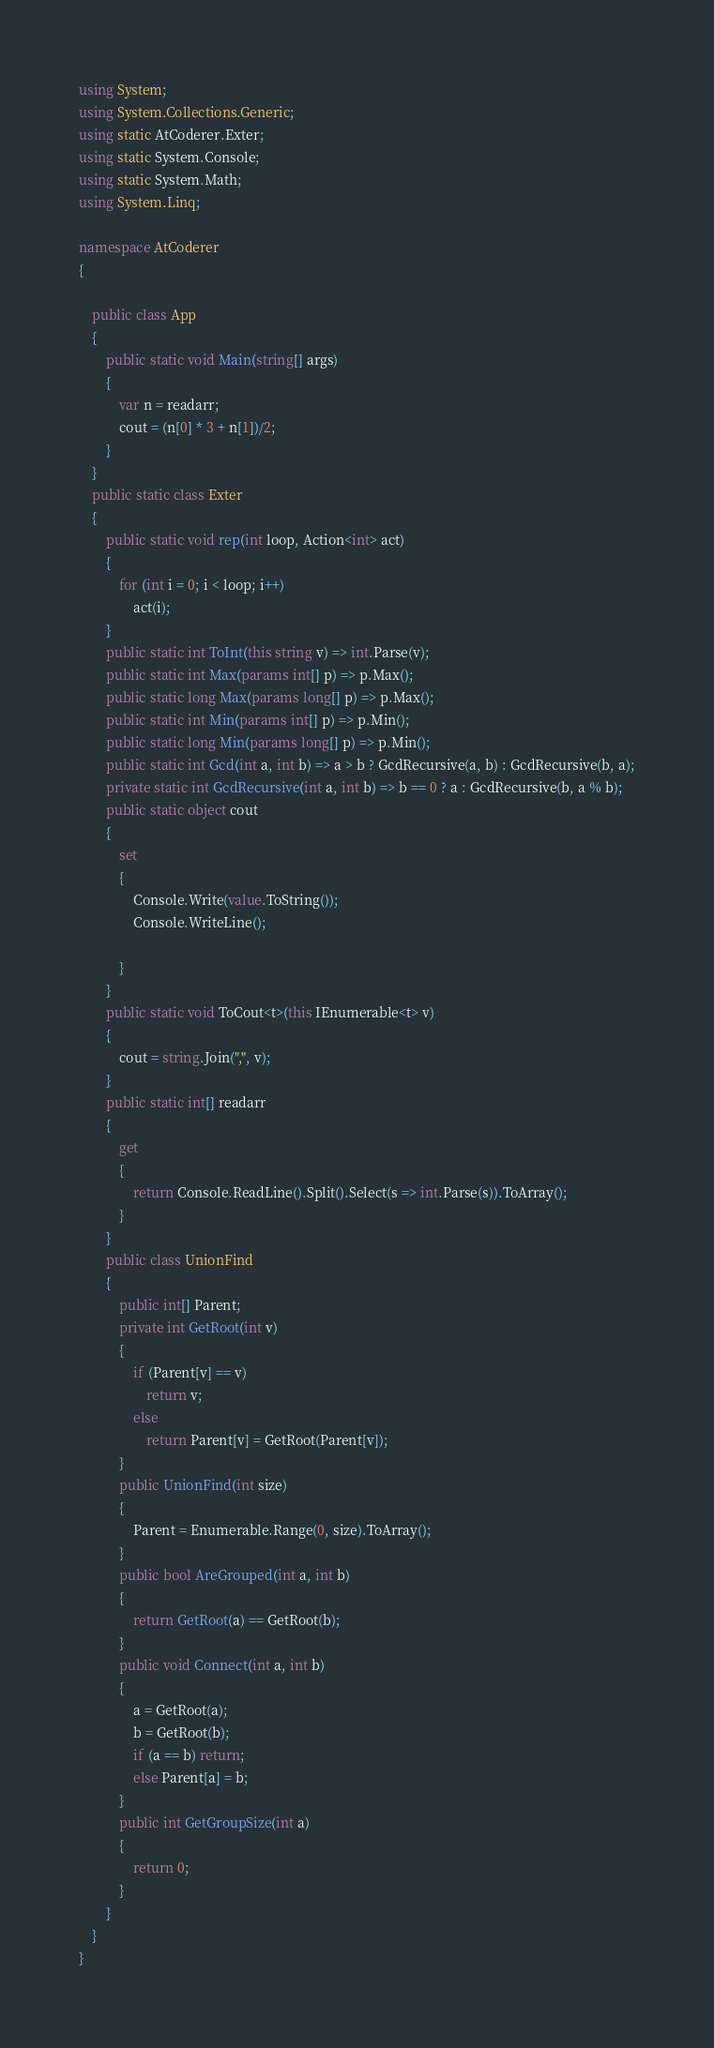<code> <loc_0><loc_0><loc_500><loc_500><_C#_>using System;
using System.Collections.Generic;
using static AtCoderer.Exter;
using static System.Console;
using static System.Math;
using System.Linq;

namespace AtCoderer
{

    public class App
    {
        public static void Main(string[] args)
        {
            var n = readarr;
            cout = (n[0] * 3 + n[1])/2;
        }
    }
    public static class Exter
    {
        public static void rep(int loop, Action<int> act)
        {
            for (int i = 0; i < loop; i++)
                act(i);
        }
        public static int ToInt(this string v) => int.Parse(v);
        public static int Max(params int[] p) => p.Max();
        public static long Max(params long[] p) => p.Max();
        public static int Min(params int[] p) => p.Min();
        public static long Min(params long[] p) => p.Min();
        public static int Gcd(int a, int b) => a > b ? GcdRecursive(a, b) : GcdRecursive(b, a);
        private static int GcdRecursive(int a, int b) => b == 0 ? a : GcdRecursive(b, a % b);
        public static object cout
        {
            set
            {
                Console.Write(value.ToString());
                Console.WriteLine();

            }
        }
        public static void ToCout<t>(this IEnumerable<t> v)
        {
            cout = string.Join(",", v);
        }
        public static int[] readarr
        {
            get
            {
                return Console.ReadLine().Split().Select(s => int.Parse(s)).ToArray();
            }
        }
        public class UnionFind
        {
            public int[] Parent;
            private int GetRoot(int v)
            {
                if (Parent[v] == v)
                    return v;
                else
                    return Parent[v] = GetRoot(Parent[v]);
            }
            public UnionFind(int size)
            {
                Parent = Enumerable.Range(0, size).ToArray();
            }
            public bool AreGrouped(int a, int b)
            {
                return GetRoot(a) == GetRoot(b);
            }
            public void Connect(int a, int b)
            {
                a = GetRoot(a);
                b = GetRoot(b);
                if (a == b) return;
                else Parent[a] = b;
            }
            public int GetGroupSize(int a)
            {
                return 0;
            }
        }
    }
}
</code> 